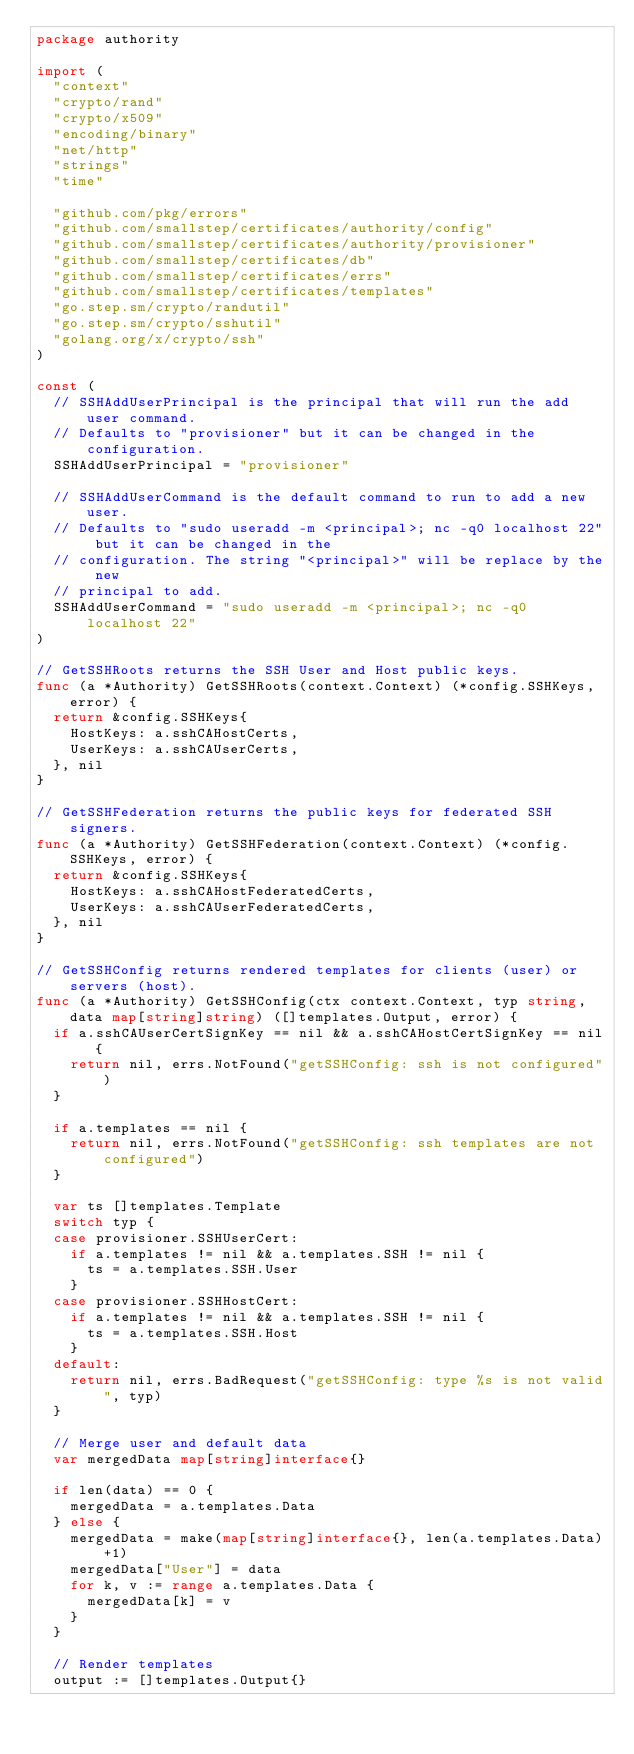Convert code to text. <code><loc_0><loc_0><loc_500><loc_500><_Go_>package authority

import (
	"context"
	"crypto/rand"
	"crypto/x509"
	"encoding/binary"
	"net/http"
	"strings"
	"time"

	"github.com/pkg/errors"
	"github.com/smallstep/certificates/authority/config"
	"github.com/smallstep/certificates/authority/provisioner"
	"github.com/smallstep/certificates/db"
	"github.com/smallstep/certificates/errs"
	"github.com/smallstep/certificates/templates"
	"go.step.sm/crypto/randutil"
	"go.step.sm/crypto/sshutil"
	"golang.org/x/crypto/ssh"
)

const (
	// SSHAddUserPrincipal is the principal that will run the add user command.
	// Defaults to "provisioner" but it can be changed in the configuration.
	SSHAddUserPrincipal = "provisioner"

	// SSHAddUserCommand is the default command to run to add a new user.
	// Defaults to "sudo useradd -m <principal>; nc -q0 localhost 22" but it can be changed in the
	// configuration. The string "<principal>" will be replace by the new
	// principal to add.
	SSHAddUserCommand = "sudo useradd -m <principal>; nc -q0 localhost 22"
)

// GetSSHRoots returns the SSH User and Host public keys.
func (a *Authority) GetSSHRoots(context.Context) (*config.SSHKeys, error) {
	return &config.SSHKeys{
		HostKeys: a.sshCAHostCerts,
		UserKeys: a.sshCAUserCerts,
	}, nil
}

// GetSSHFederation returns the public keys for federated SSH signers.
func (a *Authority) GetSSHFederation(context.Context) (*config.SSHKeys, error) {
	return &config.SSHKeys{
		HostKeys: a.sshCAHostFederatedCerts,
		UserKeys: a.sshCAUserFederatedCerts,
	}, nil
}

// GetSSHConfig returns rendered templates for clients (user) or servers (host).
func (a *Authority) GetSSHConfig(ctx context.Context, typ string, data map[string]string) ([]templates.Output, error) {
	if a.sshCAUserCertSignKey == nil && a.sshCAHostCertSignKey == nil {
		return nil, errs.NotFound("getSSHConfig: ssh is not configured")
	}

	if a.templates == nil {
		return nil, errs.NotFound("getSSHConfig: ssh templates are not configured")
	}

	var ts []templates.Template
	switch typ {
	case provisioner.SSHUserCert:
		if a.templates != nil && a.templates.SSH != nil {
			ts = a.templates.SSH.User
		}
	case provisioner.SSHHostCert:
		if a.templates != nil && a.templates.SSH != nil {
			ts = a.templates.SSH.Host
		}
	default:
		return nil, errs.BadRequest("getSSHConfig: type %s is not valid", typ)
	}

	// Merge user and default data
	var mergedData map[string]interface{}

	if len(data) == 0 {
		mergedData = a.templates.Data
	} else {
		mergedData = make(map[string]interface{}, len(a.templates.Data)+1)
		mergedData["User"] = data
		for k, v := range a.templates.Data {
			mergedData[k] = v
		}
	}

	// Render templates
	output := []templates.Output{}</code> 